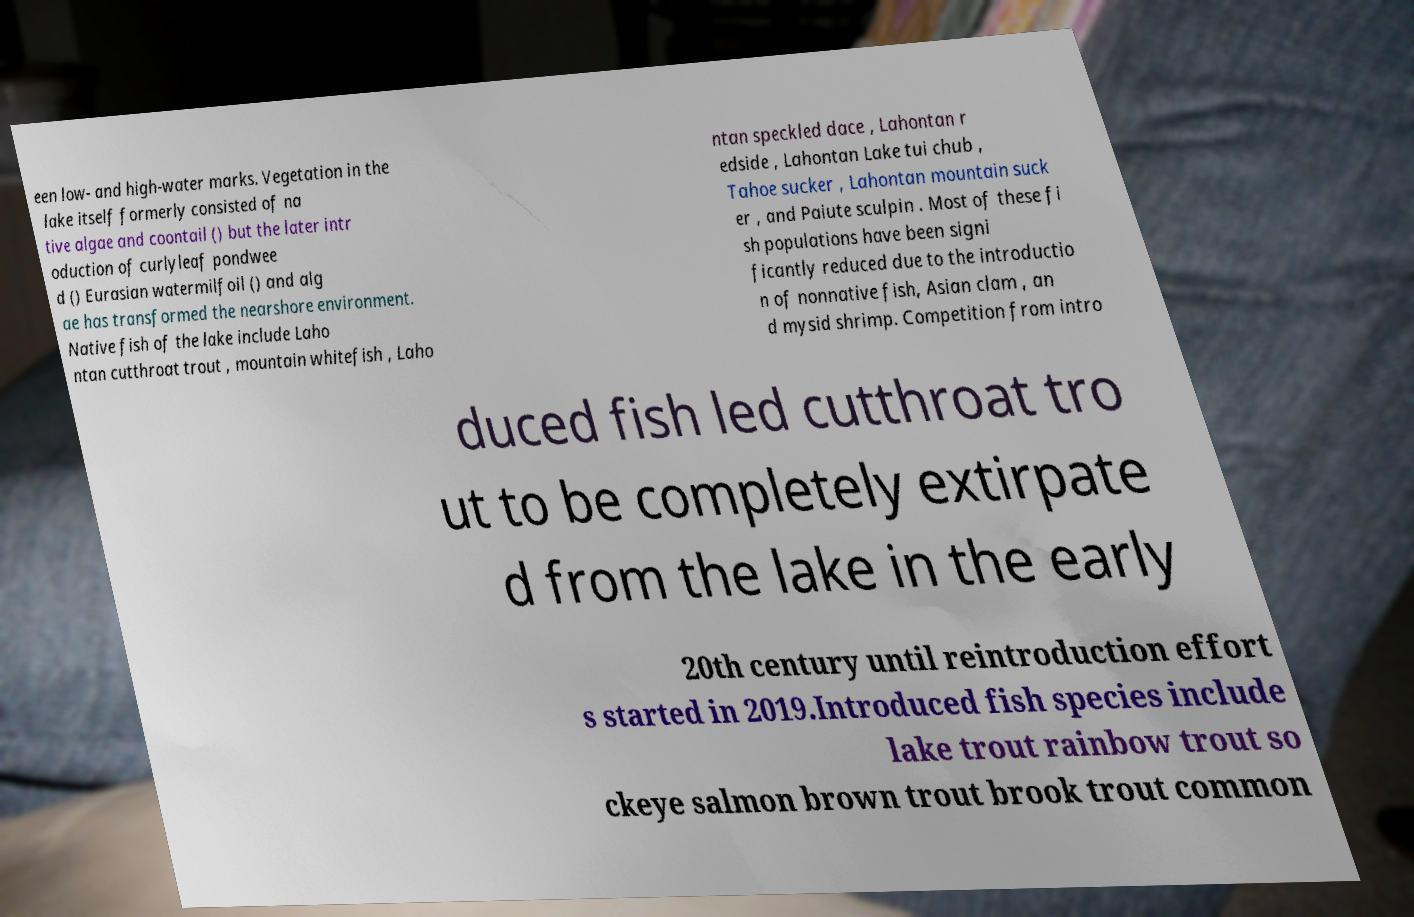Can you accurately transcribe the text from the provided image for me? een low- and high-water marks. Vegetation in the lake itself formerly consisted of na tive algae and coontail () but the later intr oduction of curlyleaf pondwee d () Eurasian watermilfoil () and alg ae has transformed the nearshore environment. Native fish of the lake include Laho ntan cutthroat trout , mountain whitefish , Laho ntan speckled dace , Lahontan r edside , Lahontan Lake tui chub , Tahoe sucker , Lahontan mountain suck er , and Paiute sculpin . Most of these fi sh populations have been signi ficantly reduced due to the introductio n of nonnative fish, Asian clam , an d mysid shrimp. Competition from intro duced fish led cutthroat tro ut to be completely extirpate d from the lake in the early 20th century until reintroduction effort s started in 2019.Introduced fish species include lake trout rainbow trout so ckeye salmon brown trout brook trout common 